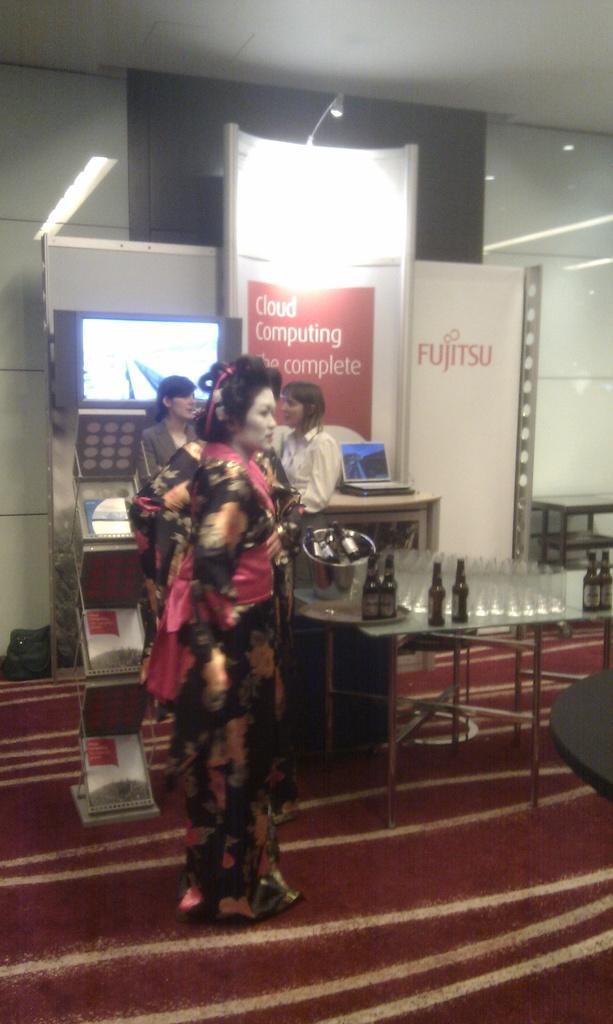Could you give a brief overview of what you see in this image? In the center of the image there are persons standing on the floor. On the right side of the image we can see laptop, beverage bottles and glasses. In the background we can see television, advertisements, light and wall. 